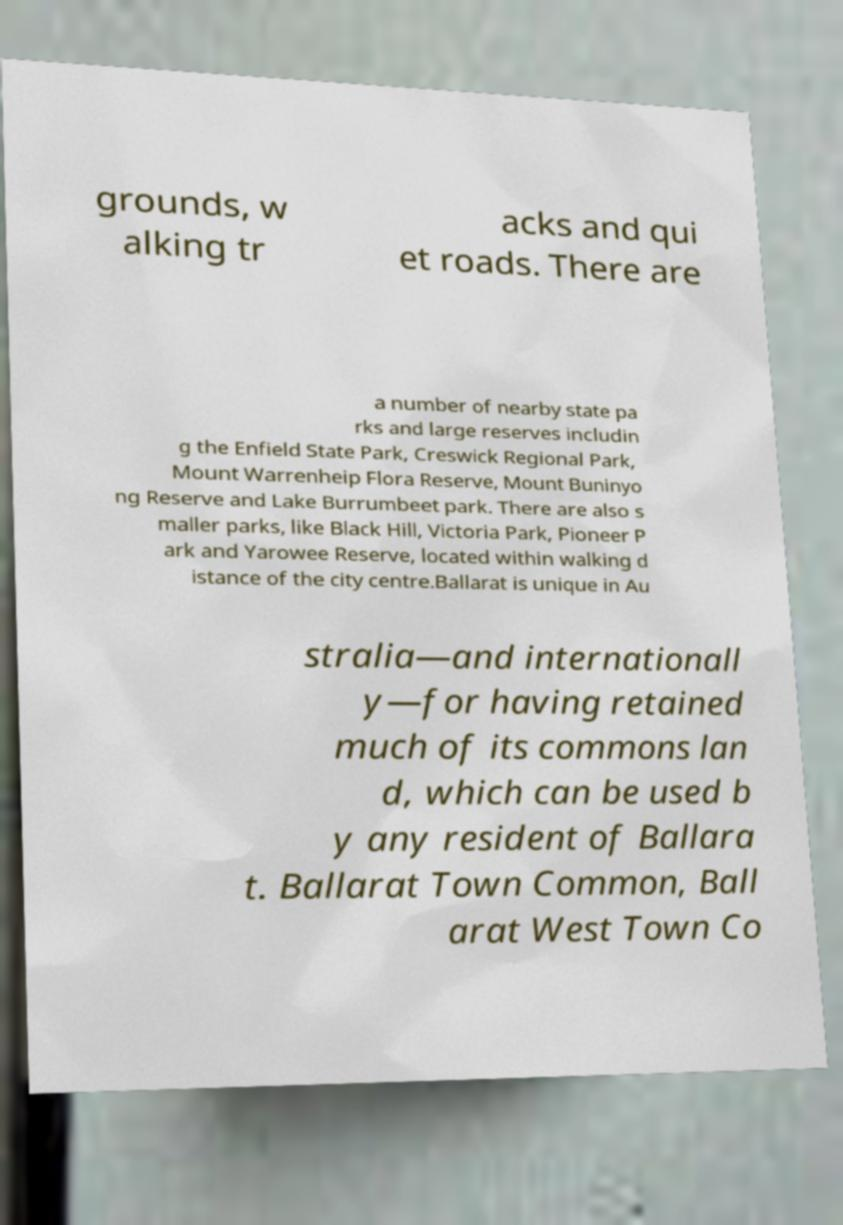Please read and relay the text visible in this image. What does it say? grounds, w alking tr acks and qui et roads. There are a number of nearby state pa rks and large reserves includin g the Enfield State Park, Creswick Regional Park, Mount Warrenheip Flora Reserve, Mount Buninyo ng Reserve and Lake Burrumbeet park. There are also s maller parks, like Black Hill, Victoria Park, Pioneer P ark and Yarowee Reserve, located within walking d istance of the city centre.Ballarat is unique in Au stralia—and internationall y—for having retained much of its commons lan d, which can be used b y any resident of Ballara t. Ballarat Town Common, Ball arat West Town Co 